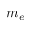<formula> <loc_0><loc_0><loc_500><loc_500>m _ { e }</formula> 